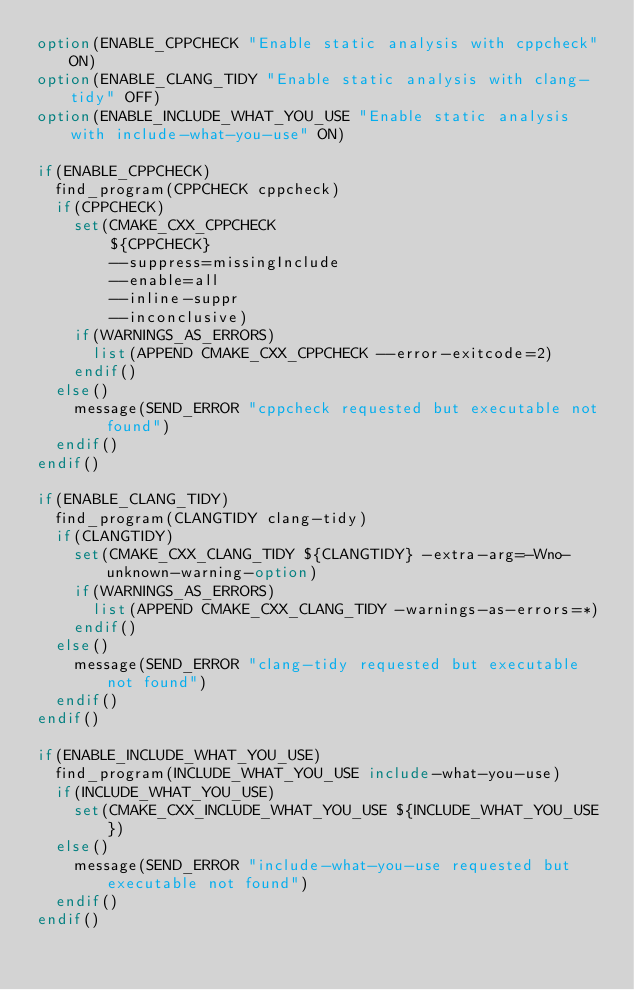<code> <loc_0><loc_0><loc_500><loc_500><_CMake_>option(ENABLE_CPPCHECK "Enable static analysis with cppcheck" ON)
option(ENABLE_CLANG_TIDY "Enable static analysis with clang-tidy" OFF)
option(ENABLE_INCLUDE_WHAT_YOU_USE "Enable static analysis with include-what-you-use" ON)

if(ENABLE_CPPCHECK)
  find_program(CPPCHECK cppcheck)
  if(CPPCHECK)
    set(CMAKE_CXX_CPPCHECK
        ${CPPCHECK}
        --suppress=missingInclude
        --enable=all
        --inline-suppr
        --inconclusive)
    if(WARNINGS_AS_ERRORS)
      list(APPEND CMAKE_CXX_CPPCHECK --error-exitcode=2)
    endif()
  else()
    message(SEND_ERROR "cppcheck requested but executable not found")
  endif()
endif()

if(ENABLE_CLANG_TIDY)
  find_program(CLANGTIDY clang-tidy)
  if(CLANGTIDY)
    set(CMAKE_CXX_CLANG_TIDY ${CLANGTIDY} -extra-arg=-Wno-unknown-warning-option)
    if(WARNINGS_AS_ERRORS)
      list(APPEND CMAKE_CXX_CLANG_TIDY -warnings-as-errors=*)
    endif()
  else()
    message(SEND_ERROR "clang-tidy requested but executable not found")
  endif()
endif()

if(ENABLE_INCLUDE_WHAT_YOU_USE)
  find_program(INCLUDE_WHAT_YOU_USE include-what-you-use)
  if(INCLUDE_WHAT_YOU_USE)
    set(CMAKE_CXX_INCLUDE_WHAT_YOU_USE ${INCLUDE_WHAT_YOU_USE})
  else()
    message(SEND_ERROR "include-what-you-use requested but executable not found")
  endif()
endif()
</code> 